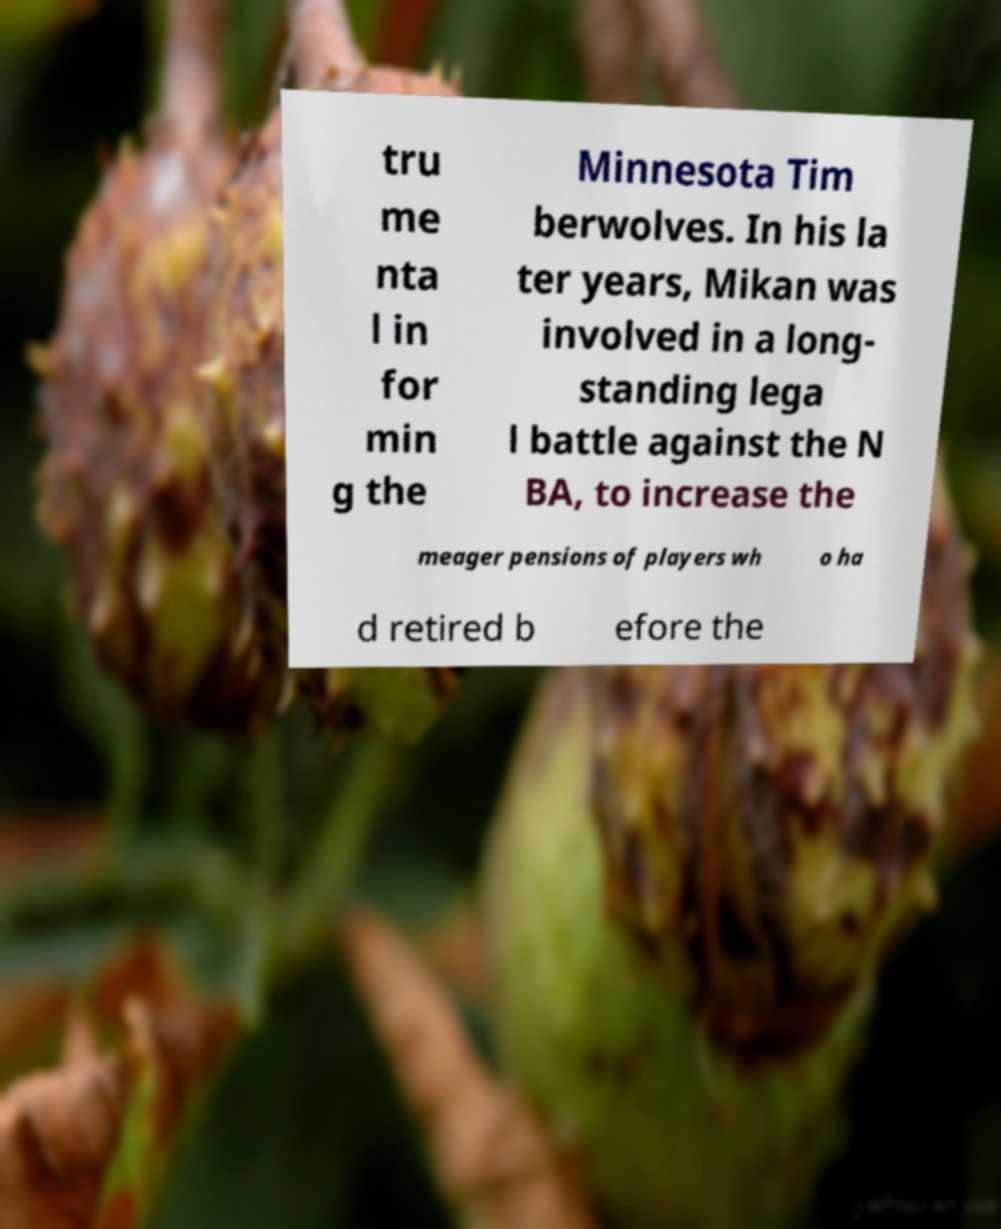Please identify and transcribe the text found in this image. tru me nta l in for min g the Minnesota Tim berwolves. In his la ter years, Mikan was involved in a long- standing lega l battle against the N BA, to increase the meager pensions of players wh o ha d retired b efore the 